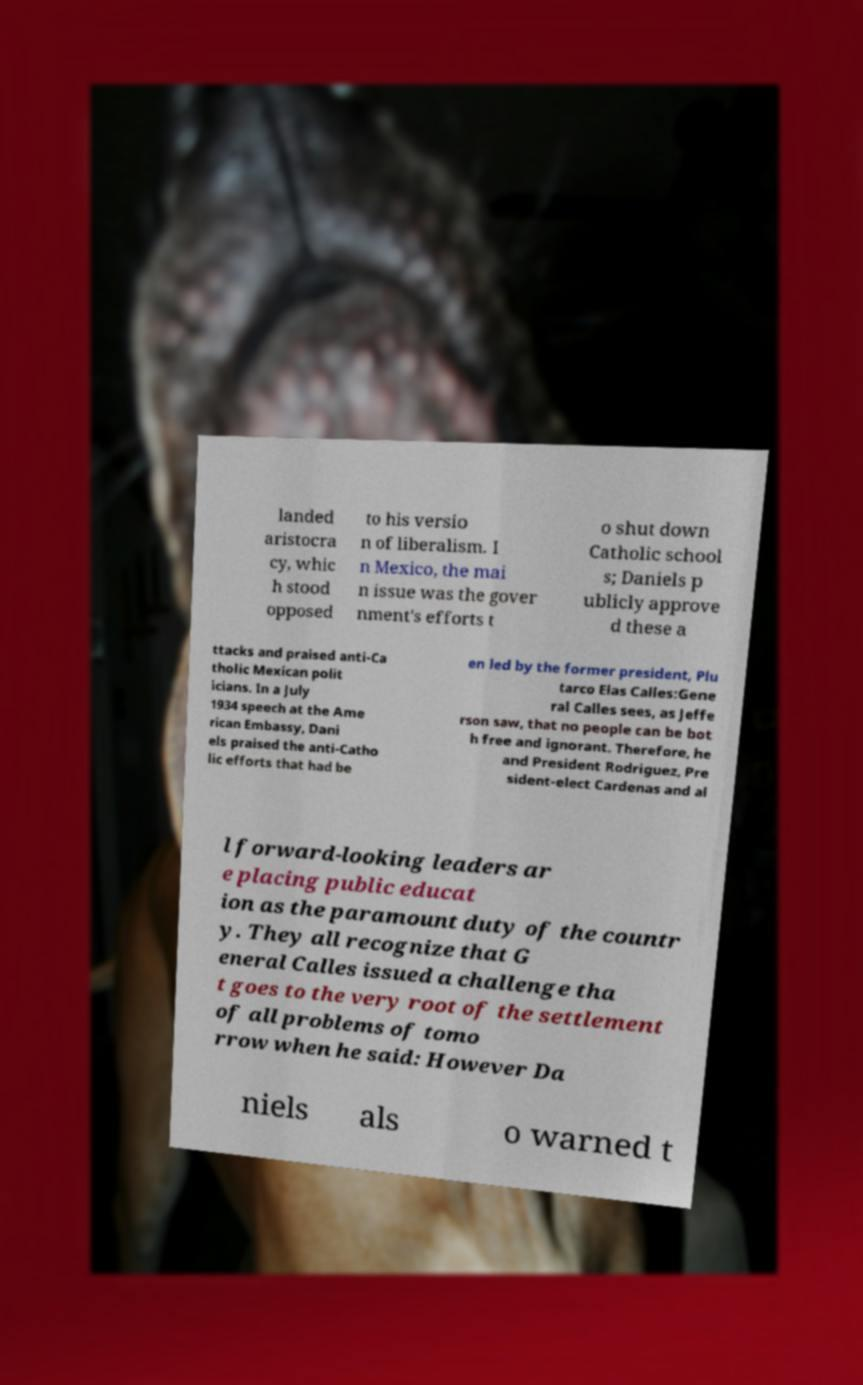Please identify and transcribe the text found in this image. landed aristocra cy, whic h stood opposed to his versio n of liberalism. I n Mexico, the mai n issue was the gover nment's efforts t o shut down Catholic school s; Daniels p ublicly approve d these a ttacks and praised anti-Ca tholic Mexican polit icians. In a July 1934 speech at the Ame rican Embassy, Dani els praised the anti-Catho lic efforts that had be en led by the former president, Plu tarco Elas Calles:Gene ral Calles sees, as Jeffe rson saw, that no people can be bot h free and ignorant. Therefore, he and President Rodriguez, Pre sident-elect Cardenas and al l forward-looking leaders ar e placing public educat ion as the paramount duty of the countr y. They all recognize that G eneral Calles issued a challenge tha t goes to the very root of the settlement of all problems of tomo rrow when he said: However Da niels als o warned t 